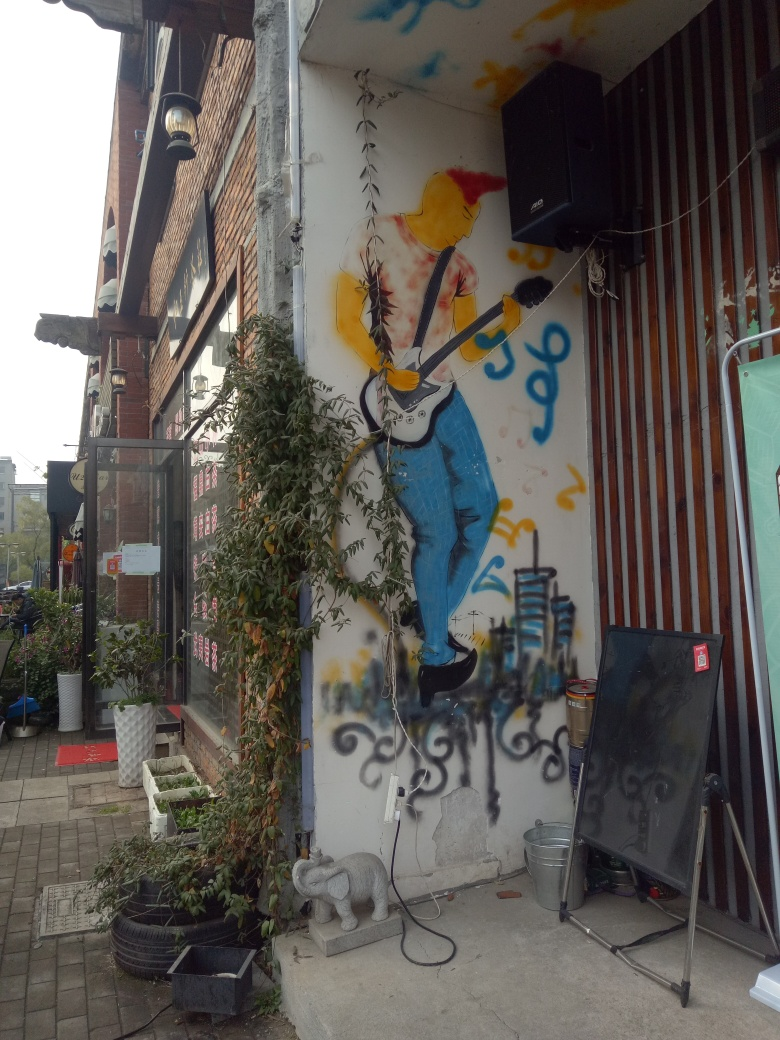How does the mural interact with its physical surroundings? The mural incorporates real-world objects into its composition, like the speaker and the plants surrounding it, blurring the line between the artwork and reality. The figure in the mural seems to be actively engaged in the environment, almost as if playing music for passersby, which adds a layer of interaction between the art and its location. 